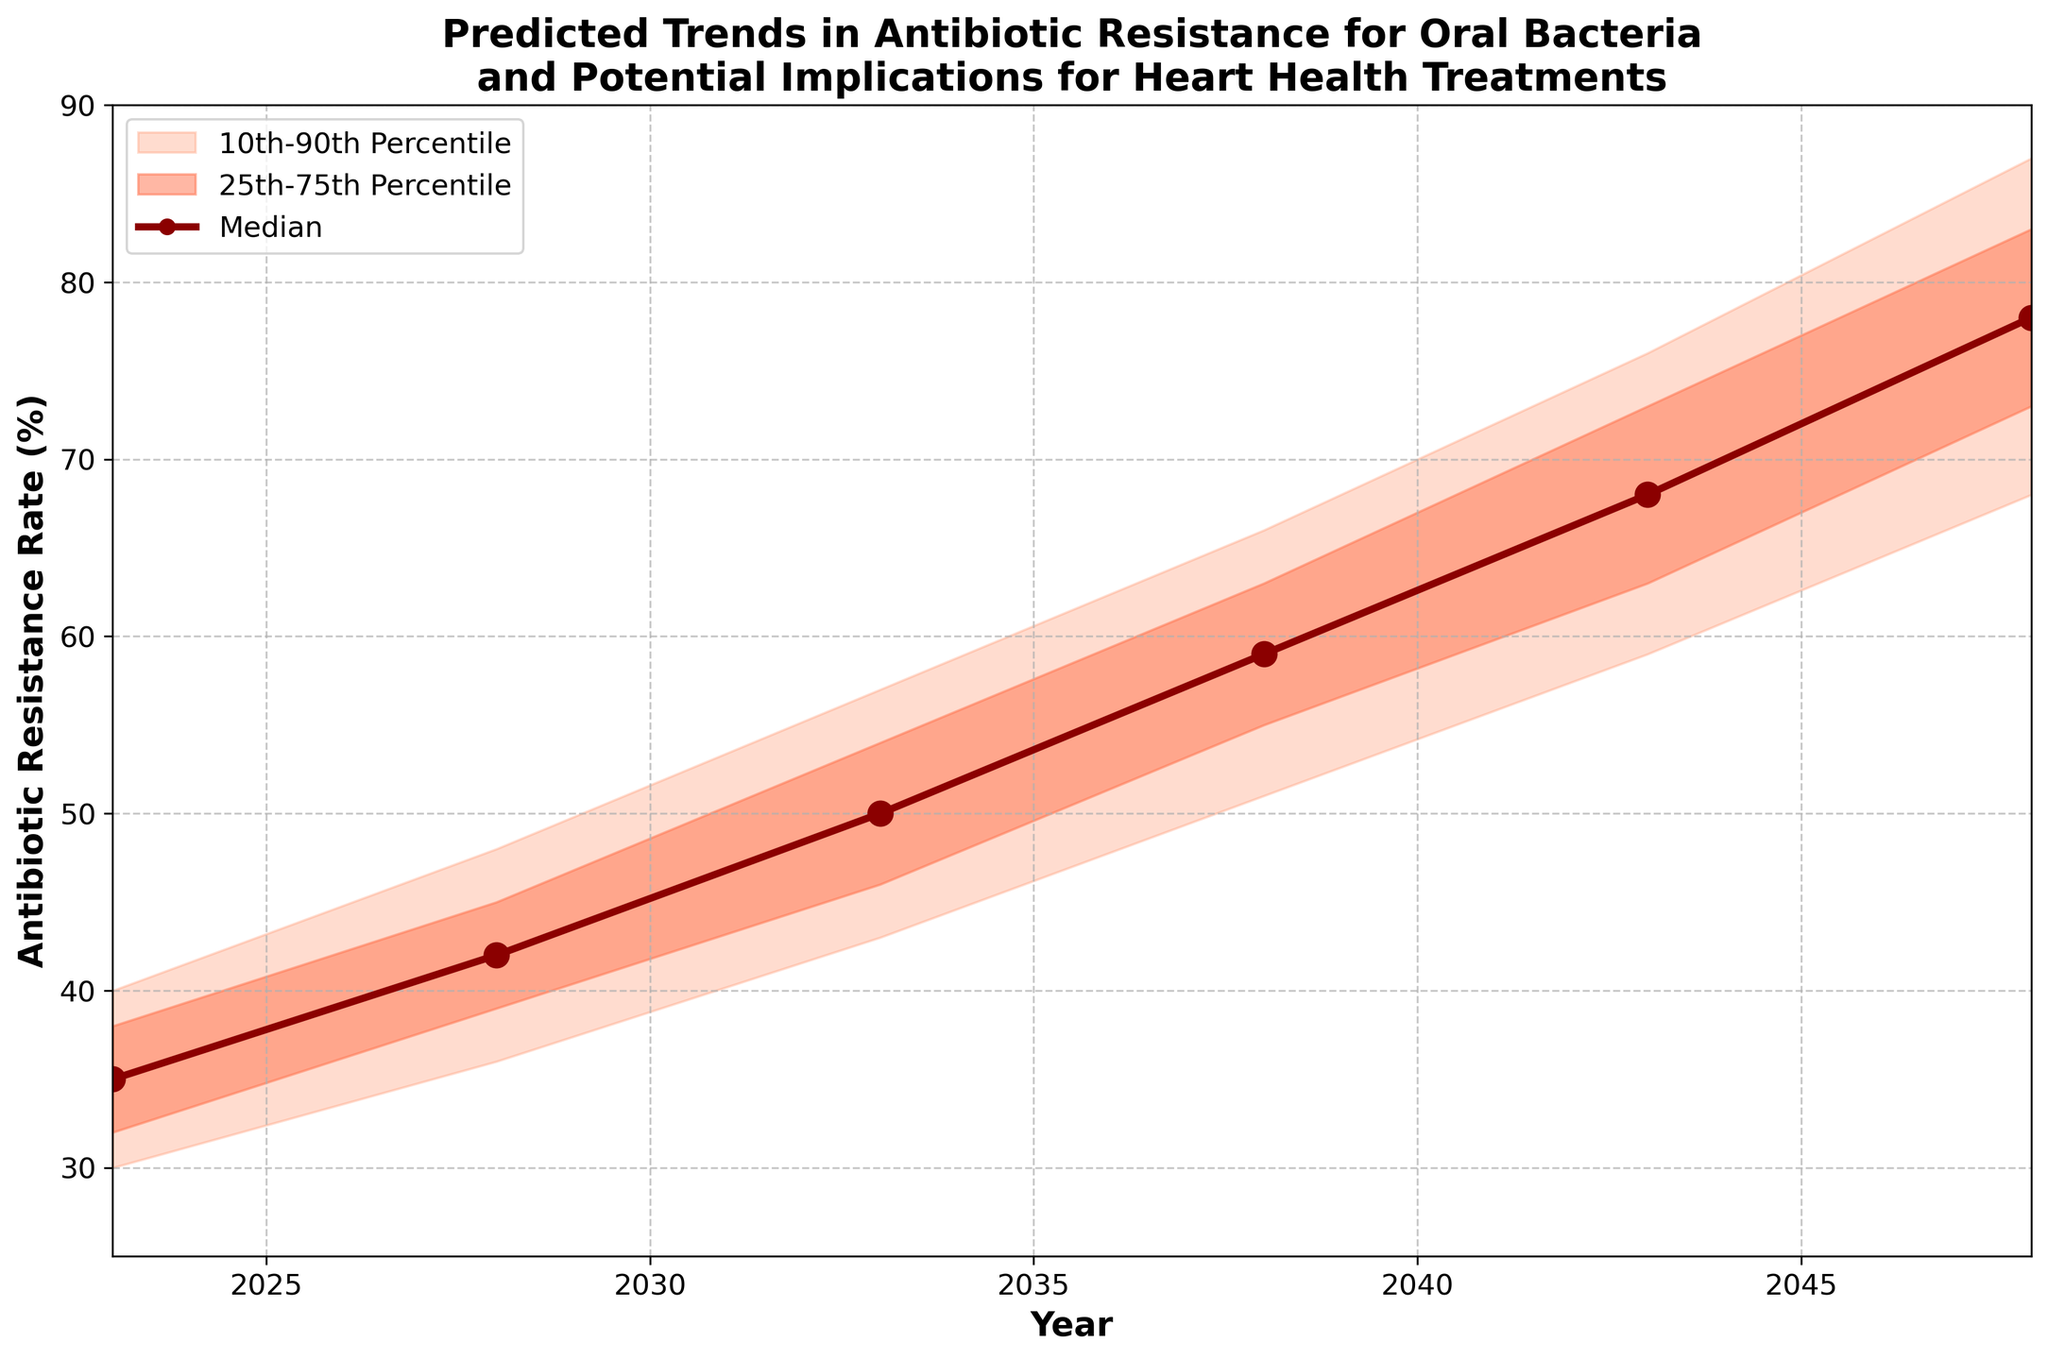How many years are presented in the figure? The x-axis shows years ranging from 2023 to 2048. By counting the years included, we can see there are 6 years presented (2023, 2028, 2033, 2038, 2043, 2048).
Answer: 6 What is the overall trend in the median antibiotic resistance rate from 2023 to 2048? By observing the plot, the median antibiotic resistance rate clearly increases over time, from 35% in 2023 to 78% in 2048.
Answer: Increasing What is the 10th percentile value for antibiotic resistance rate in 2038? The 10th percentile value for the year 2038 is shown as 51% on the chart.
Answer: 51% By how much does the upper 90th percentile value increase from 2028 to 2048? The 90th percentile value for 2028 is 48%, and for 2048 it is 87%. The increase can be calculated as 87 - 48 = 39%.
Answer: 39% What is the difference between the upper 75th percentile and the lower 25th percentile in 2043? For the year 2043, the upper 75th percentile value is 73% and the lower 25th percentile value is 63%. The difference is calculated as 73 - 63 = 10%.
Answer: 10% In which year does the median antibiotic resistance rate exceed 60%? Examining the median trend line, it exceeds 60% in the year 2038 where it reaches 59%. The next data point in 2043 has a median of 68%, hence 2038 is the year it exceeds 60%.
Answer: 2038 How do the 10th and 90th percentiles in 2048 compare with the 25th and 75th percentiles in 2033? In 2048, the 10th percentile is 68% and the 90th percentile is 87%. In 2033, the 25th percentile is 46% and the 75th percentile is 54%. 68% is higher than 46% but lower than 54%, and 87% is higher than 54%.
Answer: 68% to 87% higher than 46% to 54% How does the spread between the 10th and 90th percentiles change from 2023 to 2048? The 10th percentile in 2023 is 30%, and the 90th percentile is 40%, making the spread 10%. In 2048, the 10th percentile is 68% and the 90th percentile is 87%, making the spread 19%. The spread increases from 10% to 19% over the period.
Answer: Increases by 9% What do the shaded areas in the chart represent? The shaded areas between various percentiles represent the spread of predicted antibiotic resistance rates. The lightest shade represents the 10th to 90th percentiles, and the darker shade represents the 25th to 75th percentiles.
Answer: Percentile spreads 